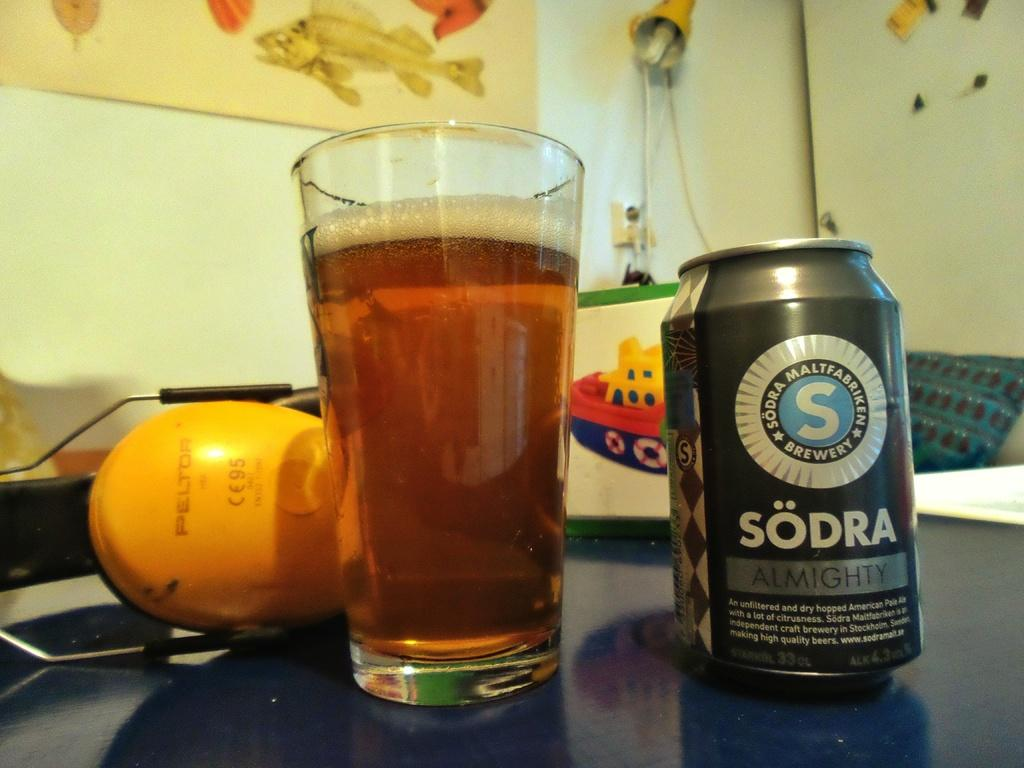<image>
Give a short and clear explanation of the subsequent image. a can of sodra almighty next to a glass of it 